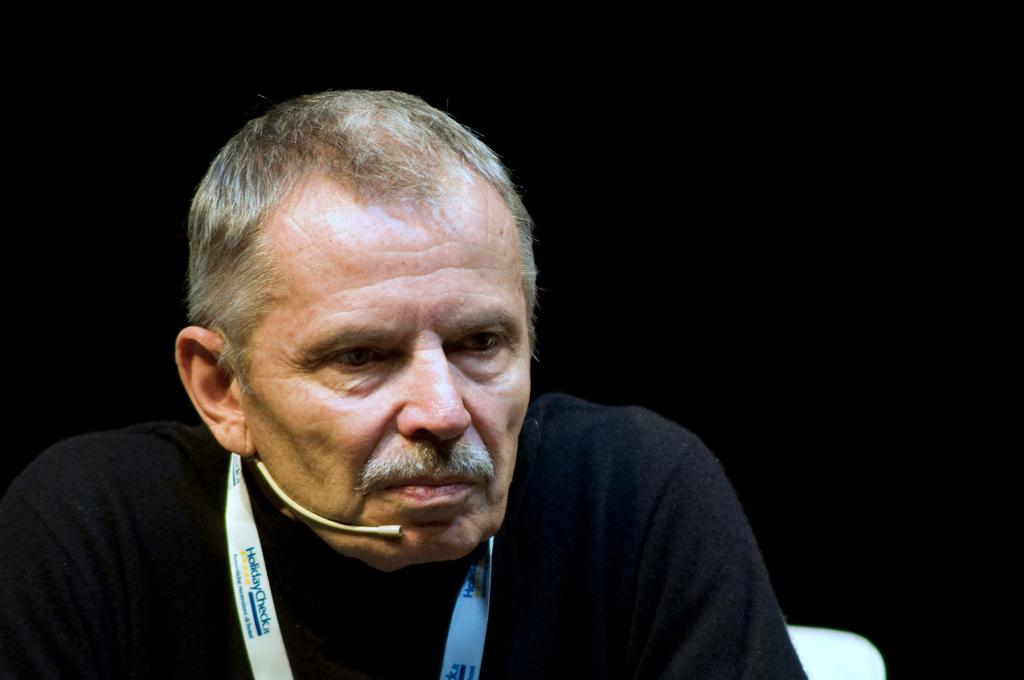Who or what is the main subject in the image? There is a person in the image. What is the person wearing? The person is wearing a black dress. What is the person doing in the image? The person is sitting on a chair. What can be observed about the background of the image? The background of the image is dark. How much paste is on the person's hands in the image? There is no paste visible on the person's hands in the image. Can you see a hen in the image? There is no hen present in the image. 